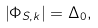<formula> <loc_0><loc_0><loc_500><loc_500>\left | \Phi _ { S , k } \right | = \Delta _ { 0 } ,</formula> 